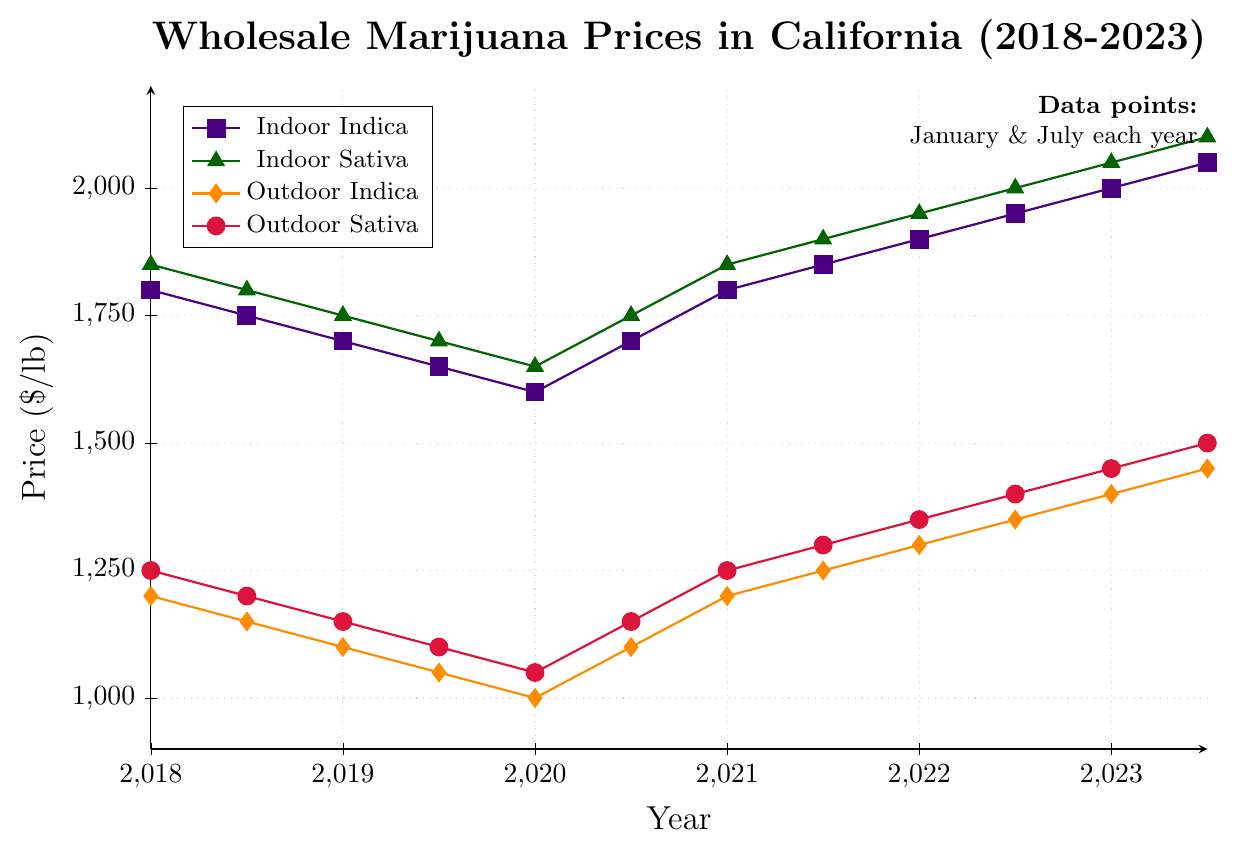What are the general trends in prices for Indoor Indica and Outdoor Indica from 2018 to 2023? Indoor Indica prices start at $1800 in January 2018, drop to $1600 in January 2020, then trend upwards to $2050 in July 2023. Outdoor Indica prices start at $1200 in January 2018, drop to $1000 in January 2020, then rise to $1450 in July 2023. Overall, both started with a decline and then showed an increasing trend.
Answer: Both followed a downward then upward trend Which type, Indoor Indica vs. Indoor Sativa, had higher prices in January 2020? In January 2020, Indoor Indica was $1600 and Indoor Sativa was $1650.
Answer: Indoor Sativa By how much did the price for Outdoor Sativa increase from January 2018 to July 2023? The price for Outdoor Sativa in January 2018 was $1250 and in July 2023 it was $1500. The difference is $1500 - $1250 = $250.
Answer: $250 In which month did the price for Outdoor Indica first exceed $1200? Outdoor Indica exceeded $1200 in January 2021. The price recorded was $1200, which is equal to but not exceeding the mark from the previous month. Only in July 2021 did the price reach this level.
Answer: January 2021 In July 2023, by how much does the price of Indoor Sativa surpass the price of Outdoor Indica? In July 2023, Indoor Sativa is $2100 and Outdoor Indica is $1450. The difference is $2100 - $1450 = $650.
Answer: $650 From the data, which type of marijuana has experienced the largest price increase from July 2020 to July 2023? Indoor Sativa price in July 2020 is $1750 and in July 2023 it is $2100. The increase is $350. For Indoor Indica, the increase is $350. For Outdoor Sativa, the increase is $350. For Outdoor Indica, the increase is $350. So, all types have had the same price increase.
Answer: All types show the same price increase of $350 Which type consistently had the lowest prices throughout the entire period shown? Outdoor Indica consistently had the lowest prices throughout the entire period 2018 to 2023.
Answer: Outdoor Indica If the difference between Indoor Indica and Indoor Sativa prices in January 2018 was maintained linearly each year until January 2021, what would it have been in January 2021? The difference in January 2018 is $1850 - $1800 = $50. If it maintained linearly, in January 2021, it would still be $50.
Answer: $50 Comparing January prices of Indoor Sativa from 2018 to 2023, what is the overall percentage increase? The Indoor Sativa price in January 2018 is $1850 and in January 2023 is $2050. The overall percentage increase is ($2050 - $1850) / $1850 * 100 = 10.81%.
Answer: 10.81% 